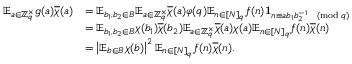Convert formula to latex. <formula><loc_0><loc_0><loc_500><loc_500>\begin{array} { r l } { \mathbb { E } _ { a \in \mathbb { Z } _ { q } ^ { \times } } g ( a ) \overline { \chi } ( a ) } & { = \mathbb { E } _ { b _ { 1 } , b _ { 2 } \in B } \mathbb { E } _ { a \in \mathbb { Z } _ { q } ^ { \times } } \overline { \chi } ( a ) \varphi ( q ) \mathbb { E } _ { n \in [ N ] _ { q } } f ( n ) 1 _ { n \equiv a b _ { 1 } b _ { 2 } ^ { - 1 } \pmod { q } } } \\ & { = \mathbb { E } _ { b _ { 1 } , b _ { 2 } \in B } \chi ( b _ { 1 } ) \overline { \chi } ( b _ { 2 } ) \mathbb { E } _ { a \in \mathbb { Z } _ { q } ^ { \times } } \overline { \chi } ( a ) \chi ( a ) \mathbb { E } _ { n \in [ N ] _ { q } } f ( n ) \overline { \chi } ( n ) } \\ & { = \left | \mathbb { E } _ { b \in B } \chi ( b ) \right | ^ { 2 } \mathbb { E } _ { n \in [ N ] _ { q } } f ( n ) \overline { \chi } ( n ) . } \end{array}</formula> 